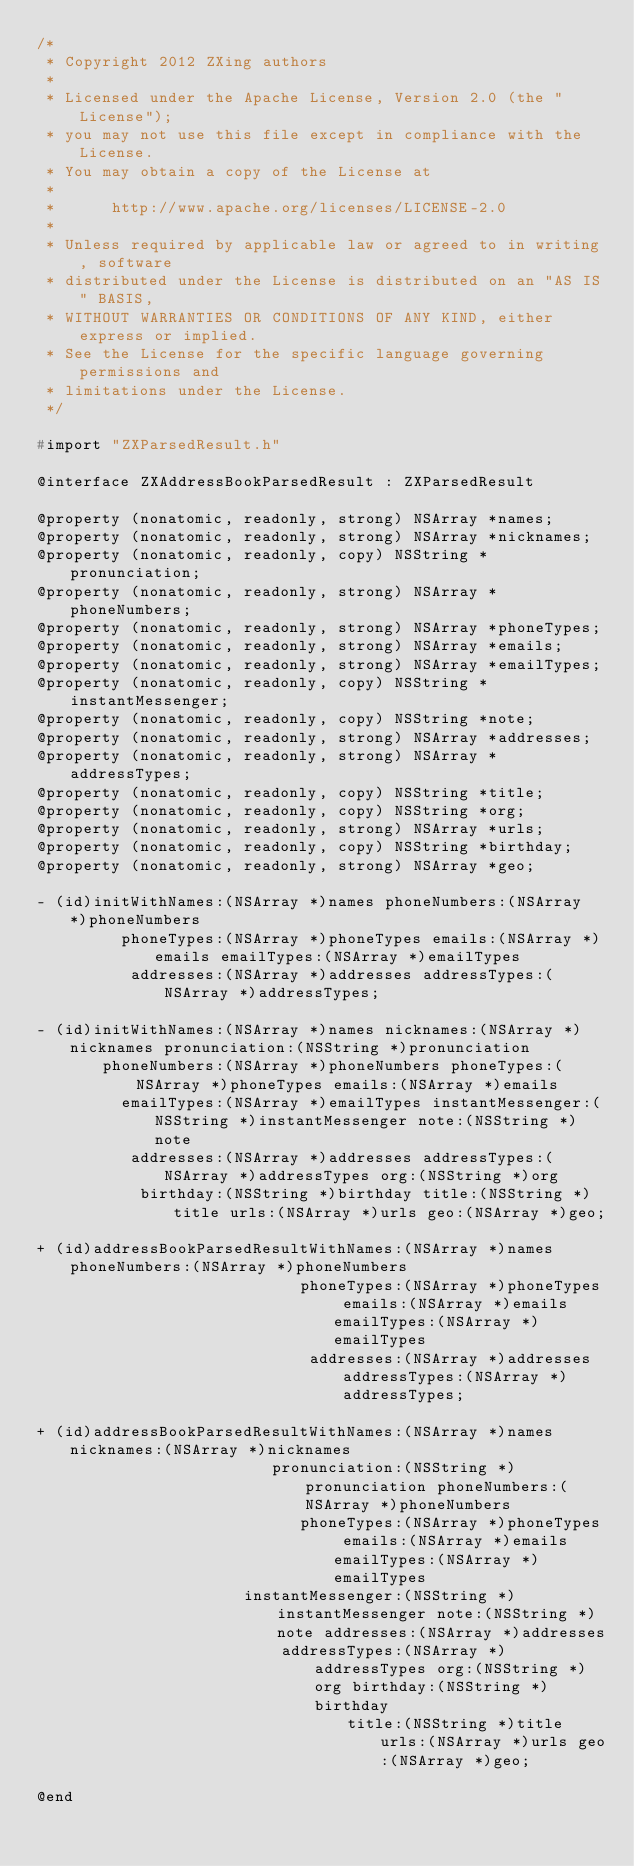<code> <loc_0><loc_0><loc_500><loc_500><_C_>/*
 * Copyright 2012 ZXing authors
 *
 * Licensed under the Apache License, Version 2.0 (the "License");
 * you may not use this file except in compliance with the License.
 * You may obtain a copy of the License at
 *
 *      http://www.apache.org/licenses/LICENSE-2.0
 *
 * Unless required by applicable law or agreed to in writing, software
 * distributed under the License is distributed on an "AS IS" BASIS,
 * WITHOUT WARRANTIES OR CONDITIONS OF ANY KIND, either express or implied.
 * See the License for the specific language governing permissions and
 * limitations under the License.
 */

#import "ZXParsedResult.h"

@interface ZXAddressBookParsedResult : ZXParsedResult

@property (nonatomic, readonly, strong) NSArray *names;
@property (nonatomic, readonly, strong) NSArray *nicknames;
@property (nonatomic, readonly, copy) NSString *pronunciation;
@property (nonatomic, readonly, strong) NSArray *phoneNumbers;
@property (nonatomic, readonly, strong) NSArray *phoneTypes;
@property (nonatomic, readonly, strong) NSArray *emails;
@property (nonatomic, readonly, strong) NSArray *emailTypes;
@property (nonatomic, readonly, copy) NSString *instantMessenger;
@property (nonatomic, readonly, copy) NSString *note;
@property (nonatomic, readonly, strong) NSArray *addresses;
@property (nonatomic, readonly, strong) NSArray *addressTypes;
@property (nonatomic, readonly, copy) NSString *title;
@property (nonatomic, readonly, copy) NSString *org;
@property (nonatomic, readonly, strong) NSArray *urls;
@property (nonatomic, readonly, copy) NSString *birthday;
@property (nonatomic, readonly, strong) NSArray *geo;

- (id)initWithNames:(NSArray *)names phoneNumbers:(NSArray *)phoneNumbers
         phoneTypes:(NSArray *)phoneTypes emails:(NSArray *)emails emailTypes:(NSArray *)emailTypes
          addresses:(NSArray *)addresses addressTypes:(NSArray *)addressTypes;

- (id)initWithNames:(NSArray *)names nicknames:(NSArray *)nicknames pronunciation:(NSString *)pronunciation
       phoneNumbers:(NSArray *)phoneNumbers phoneTypes:(NSArray *)phoneTypes emails:(NSArray *)emails
         emailTypes:(NSArray *)emailTypes instantMessenger:(NSString *)instantMessenger note:(NSString *)note
          addresses:(NSArray *)addresses addressTypes:(NSArray *)addressTypes org:(NSString *)org
           birthday:(NSString *)birthday title:(NSString *)title urls:(NSArray *)urls geo:(NSArray *)geo;

+ (id)addressBookParsedResultWithNames:(NSArray *)names phoneNumbers:(NSArray *)phoneNumbers
                            phoneTypes:(NSArray *)phoneTypes emails:(NSArray *)emails emailTypes:(NSArray *)emailTypes
                             addresses:(NSArray *)addresses addressTypes:(NSArray *)addressTypes;

+ (id)addressBookParsedResultWithNames:(NSArray *)names nicknames:(NSArray *)nicknames
                         pronunciation:(NSString *)pronunciation phoneNumbers:(NSArray *)phoneNumbers
                            phoneTypes:(NSArray *)phoneTypes emails:(NSArray *)emails emailTypes:(NSArray *)emailTypes
                      instantMessenger:(NSString *)instantMessenger note:(NSString *)note addresses:(NSArray *)addresses
                          addressTypes:(NSArray *)addressTypes org:(NSString *)org birthday:(NSString *)birthday
                                 title:(NSString *)title urls:(NSArray *)urls geo:(NSArray *)geo;

@end
</code> 